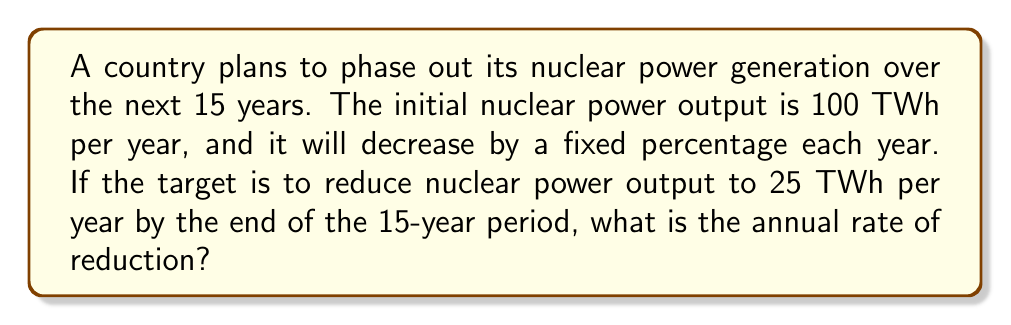Provide a solution to this math problem. To solve this problem, we need to use the concept of geometric sequences and the formula for the nth term of a geometric sequence.

Let $r$ be the annual rate of reduction (as a decimal), where the remaining fraction each year is $(1-r)$.

1) Initial value: $a_1 = 100$ TWh
2) Final value after 15 years: $a_{15} = 25$ TWh
3) Number of terms: $n = 15$

Using the formula for the nth term of a geometric sequence:
$a_n = a_1 \cdot (1-r)^{n-1}$

Substituting our values:
$25 = 100 \cdot (1-r)^{14}$

Simplifying:
$\frac{1}{4} = (1-r)^{14}$

Taking the 14th root of both sides:
$\sqrt[14]{\frac{1}{4}} = 1-r$

$r = 1 - \sqrt[14]{\frac{1}{4}}$

$r \approx 0.0917$ or $9.17\%$

Therefore, the annual rate of reduction in nuclear power generation is approximately 9.17%.
Answer: 9.17% 